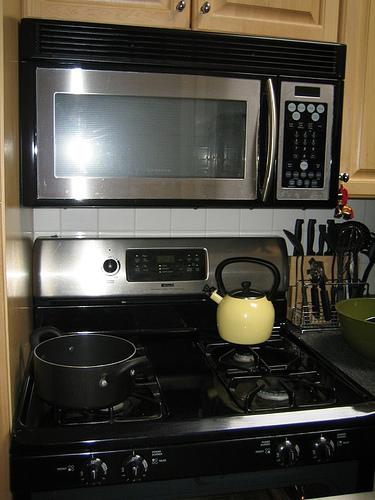Is this a toaster oven?
Give a very brief answer. No. Is the stove on?
Concise answer only. No. What is on the right side of the stove with the handle?
Answer briefly. Tea pot. What number is displayed on the microwave?
Concise answer only. 1. Is the oven on?
Short answer required. No. Is the pan empty?
Concise answer only. Yes. Is this a gas stove?
Concise answer only. Yes. 